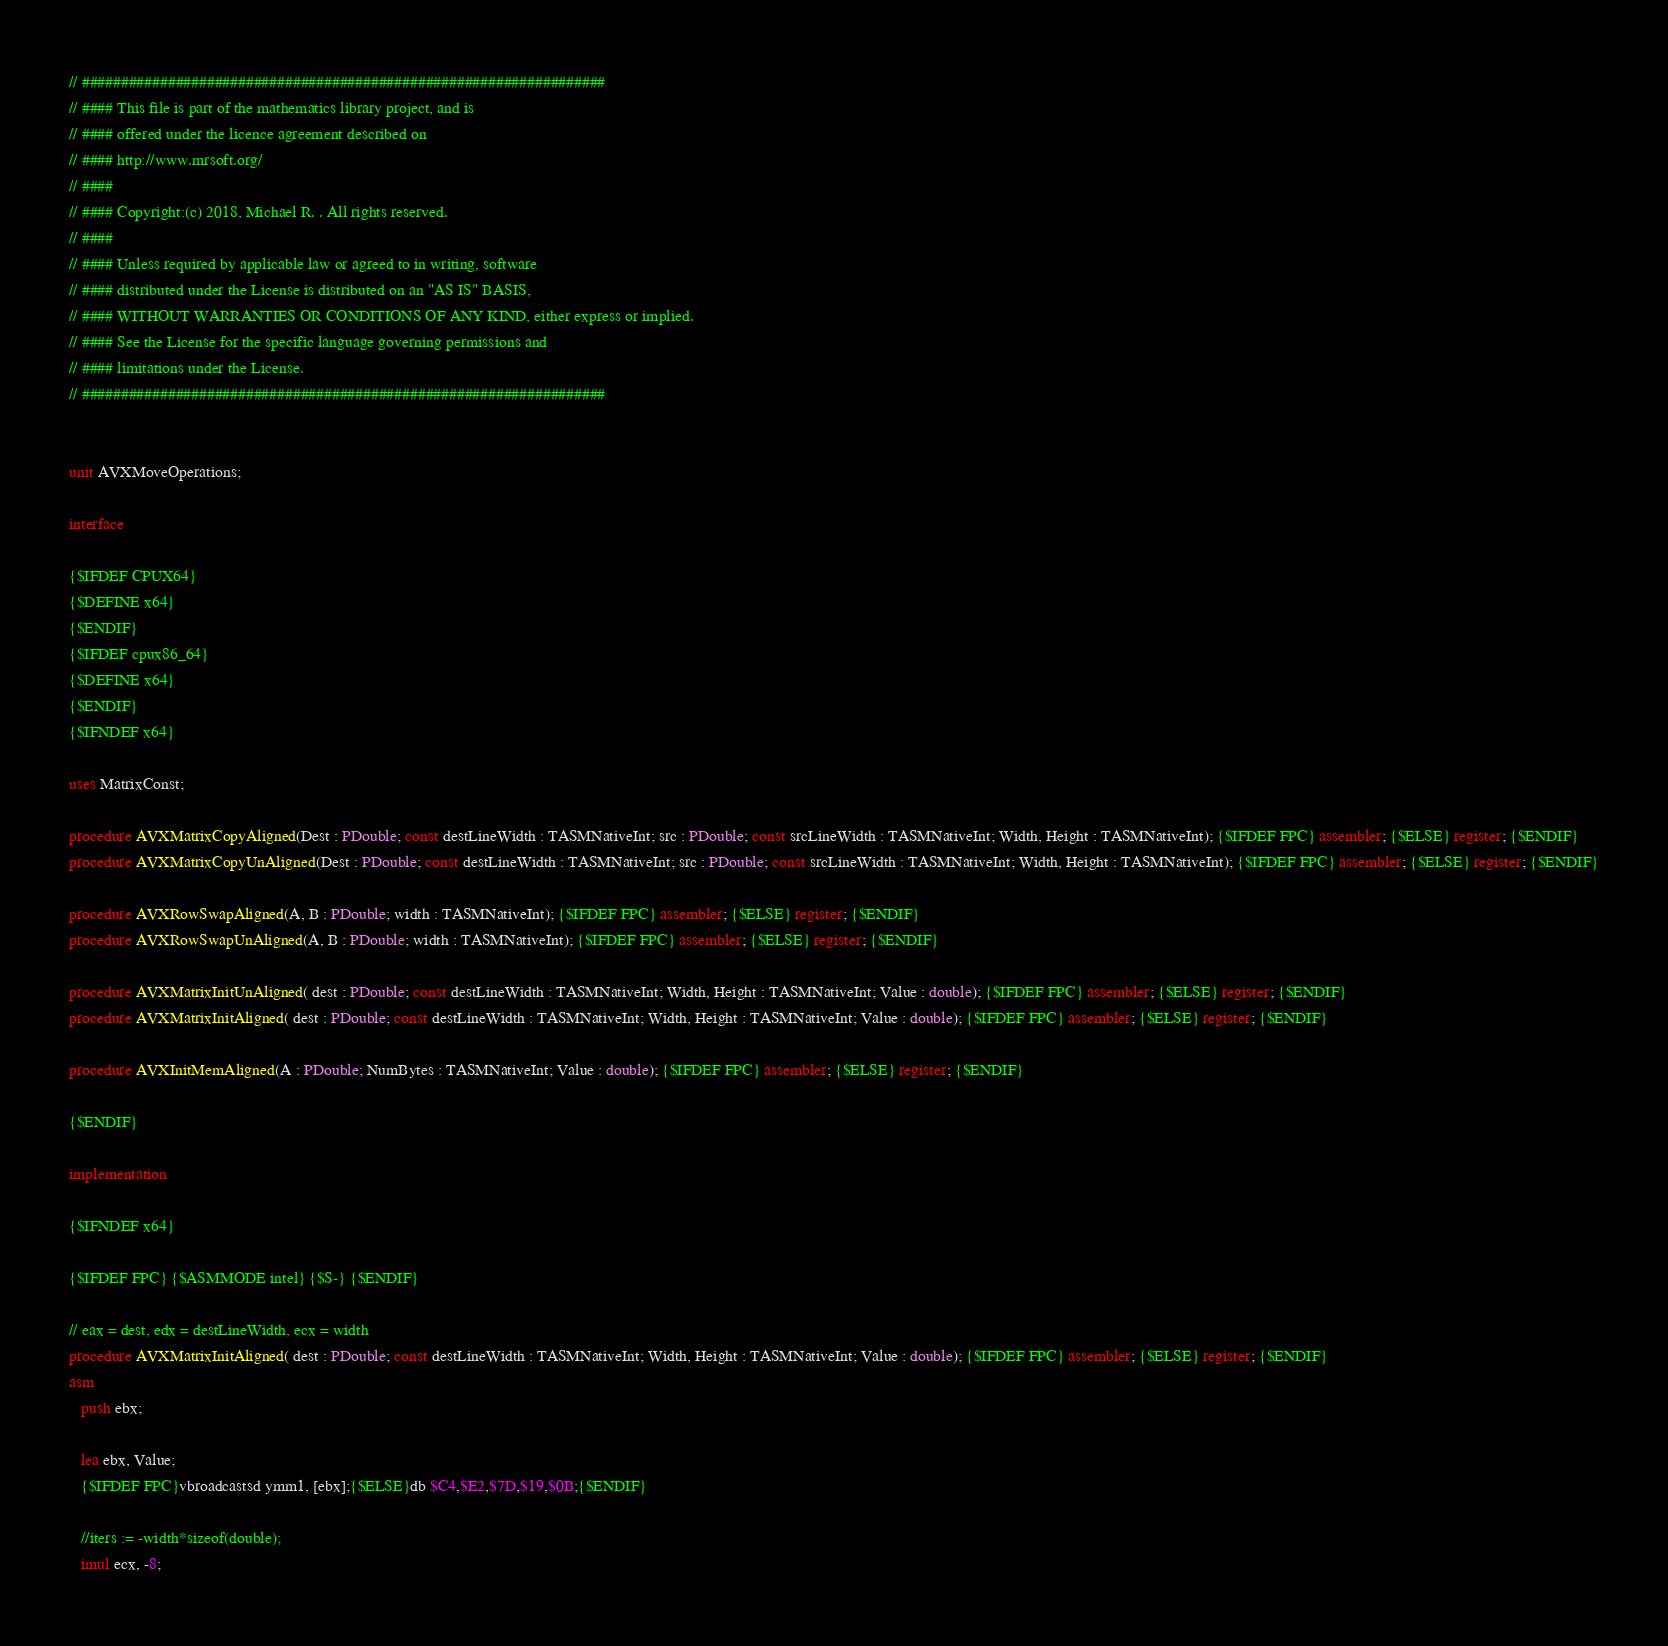<code> <loc_0><loc_0><loc_500><loc_500><_Pascal_>// ###################################################################
// #### This file is part of the mathematics library project, and is
// #### offered under the licence agreement described on
// #### http://www.mrsoft.org/
// ####
// #### Copyright:(c) 2018, Michael R. . All rights reserved.
// ####
// #### Unless required by applicable law or agreed to in writing, software
// #### distributed under the License is distributed on an "AS IS" BASIS,
// #### WITHOUT WARRANTIES OR CONDITIONS OF ANY KIND, either express or implied.
// #### See the License for the specific language governing permissions and
// #### limitations under the License.
// ###################################################################


unit AVXMoveOperations;

interface

{$IFDEF CPUX64}
{$DEFINE x64}
{$ENDIF}
{$IFDEF cpux86_64}
{$DEFINE x64}
{$ENDIF}
{$IFNDEF x64}

uses MatrixConst;

procedure AVXMatrixCopyAligned(Dest : PDouble; const destLineWidth : TASMNativeInt; src : PDouble; const srcLineWidth : TASMNativeInt; Width, Height : TASMNativeInt); {$IFDEF FPC} assembler; {$ELSE} register; {$ENDIF}
procedure AVXMatrixCopyUnAligned(Dest : PDouble; const destLineWidth : TASMNativeInt; src : PDouble; const srcLineWidth : TASMNativeInt; Width, Height : TASMNativeInt); {$IFDEF FPC} assembler; {$ELSE} register; {$ENDIF}

procedure AVXRowSwapAligned(A, B : PDouble; width : TASMNativeInt); {$IFDEF FPC} assembler; {$ELSE} register; {$ENDIF}
procedure AVXRowSwapUnAligned(A, B : PDouble; width : TASMNativeInt); {$IFDEF FPC} assembler; {$ELSE} register; {$ENDIF}

procedure AVXMatrixInitUnAligned( dest : PDouble; const destLineWidth : TASMNativeInt; Width, Height : TASMNativeInt; Value : double); {$IFDEF FPC} assembler; {$ELSE} register; {$ENDIF}
procedure AVXMatrixInitAligned( dest : PDouble; const destLineWidth : TASMNativeInt; Width, Height : TASMNativeInt; Value : double); {$IFDEF FPC} assembler; {$ELSE} register; {$ENDIF}

procedure AVXInitMemAligned(A : PDouble; NumBytes : TASMNativeInt; Value : double); {$IFDEF FPC} assembler; {$ELSE} register; {$ENDIF}

{$ENDIF}

implementation

{$IFNDEF x64}

{$IFDEF FPC} {$ASMMODE intel} {$S-} {$ENDIF}

// eax = dest, edx = destLineWidth, ecx = width
procedure AVXMatrixInitAligned( dest : PDouble; const destLineWidth : TASMNativeInt; Width, Height : TASMNativeInt; Value : double); {$IFDEF FPC} assembler; {$ELSE} register; {$ENDIF}
asm
   push ebx;

   lea ebx, Value;
   {$IFDEF FPC}vbroadcastsd ymm1, [ebx];{$ELSE}db $C4,$E2,$7D,$19,$0B;{$ENDIF} 

   //iters := -width*sizeof(double);
   imul ecx, -8;
</code> 